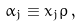<formula> <loc_0><loc_0><loc_500><loc_500>\alpha _ { j } \equiv x _ { j } \varrho \, ,</formula> 